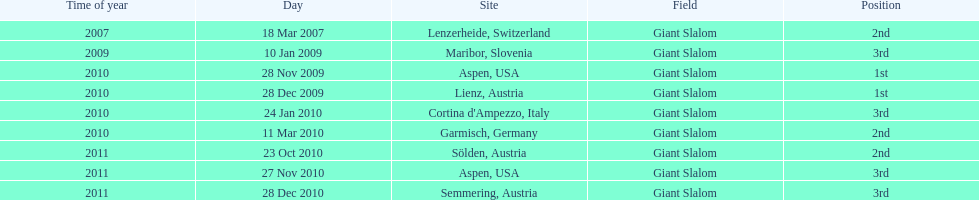What was the finishing place of the last race in december 2010? 3rd. 